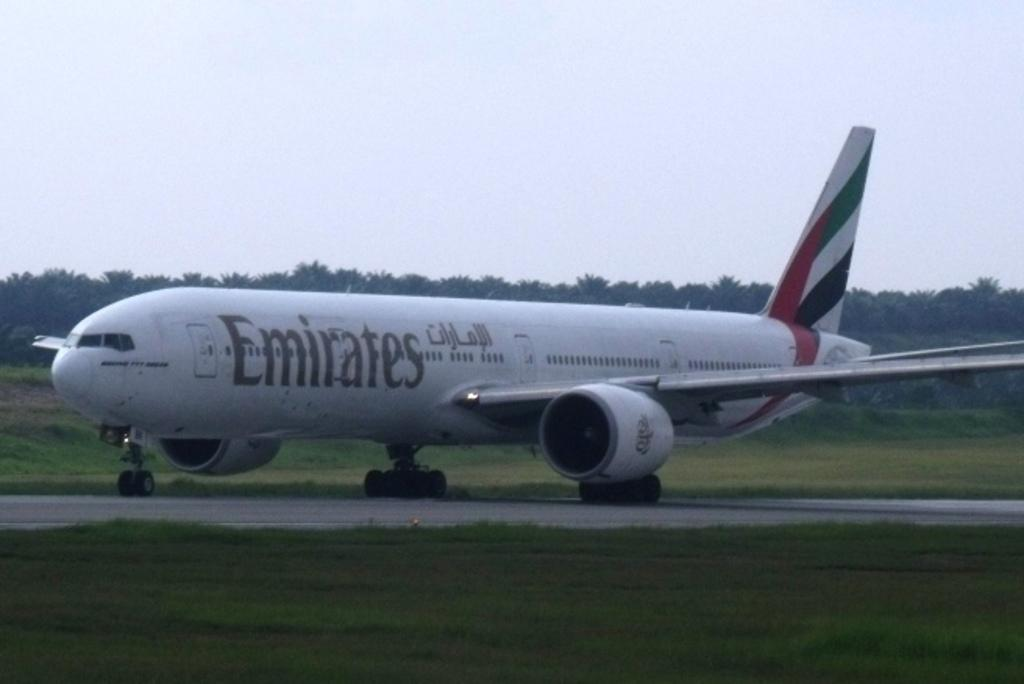What is the main subject of the image? The main subject of the image is an airplane. Where is the airplane located in the image? The airplane is on a runway. What type of vegetation can be seen in the background of the image? There is grass visible in the background of the image. What else can be seen in the background of the image? There are trees in the background of the image. How many doctors are present in the image? There are no doctors present in the image; it features an airplane on a runway. What type of friction is occurring between the airplane and the runway? The provided facts do not mention any friction between the airplane and the runway, so it cannot be determined from the image. 